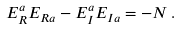<formula> <loc_0><loc_0><loc_500><loc_500>E _ { R } ^ { a } E _ { R a } - E _ { I } ^ { a } E _ { I a } = - N \, .</formula> 